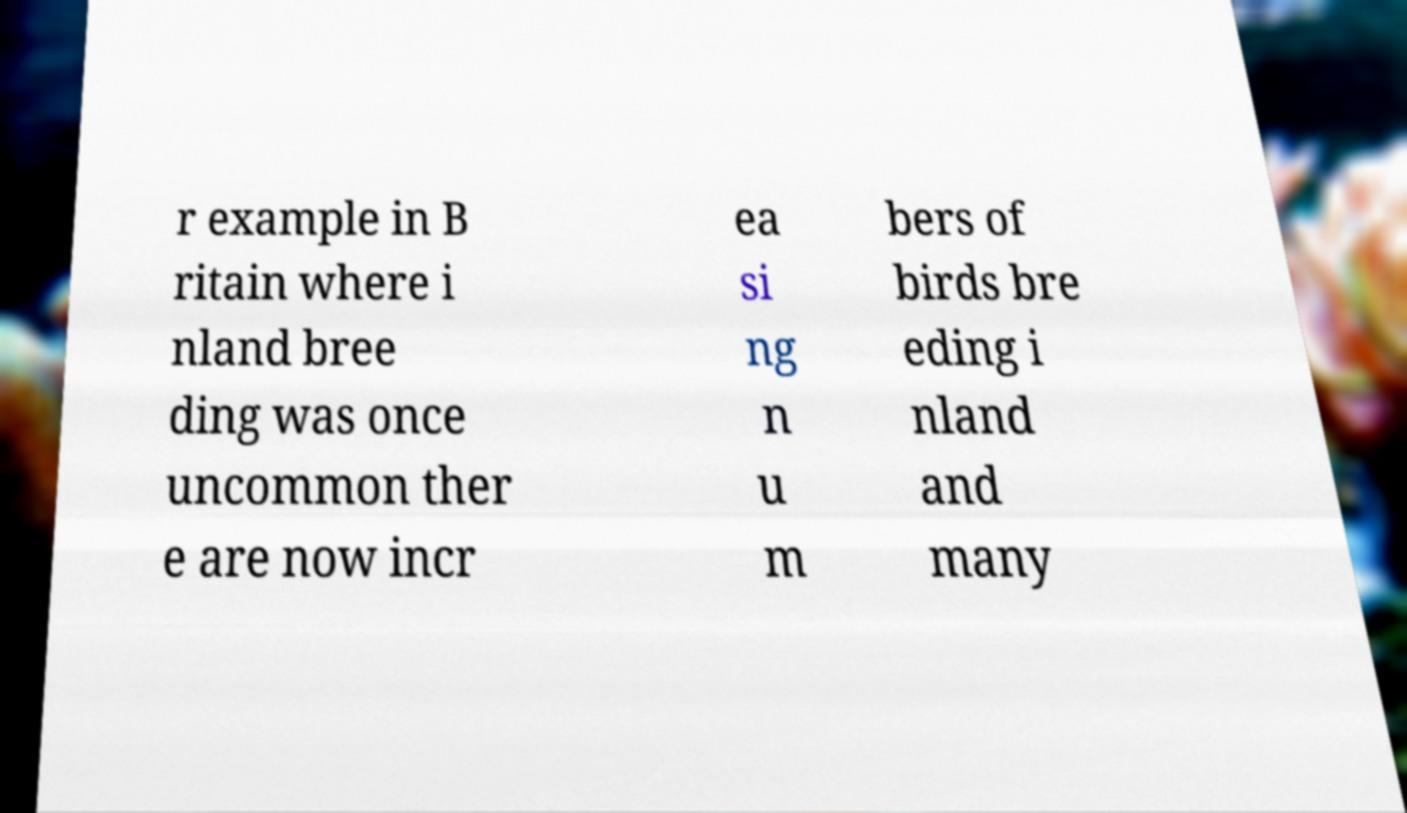Please identify and transcribe the text found in this image. r example in B ritain where i nland bree ding was once uncommon ther e are now incr ea si ng n u m bers of birds bre eding i nland and many 